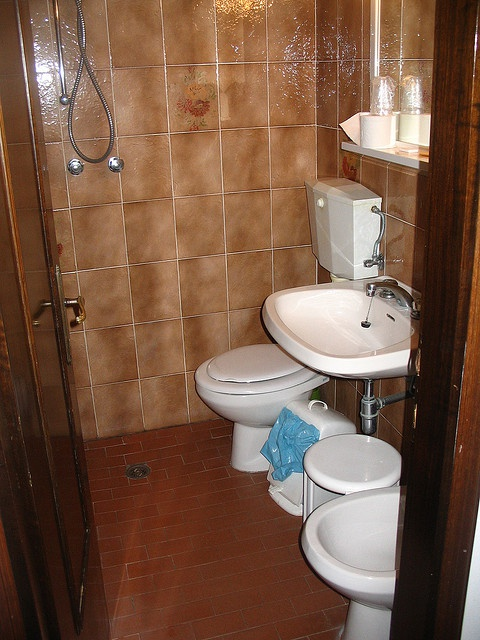Describe the objects in this image and their specific colors. I can see sink in maroon, lightgray, darkgray, and tan tones, toilet in maroon, lightgray, darkgray, and gray tones, toilet in maroon, darkgray, lightgray, and gray tones, cup in maroon, white, and tan tones, and cup in maroon, lightgray, and tan tones in this image. 